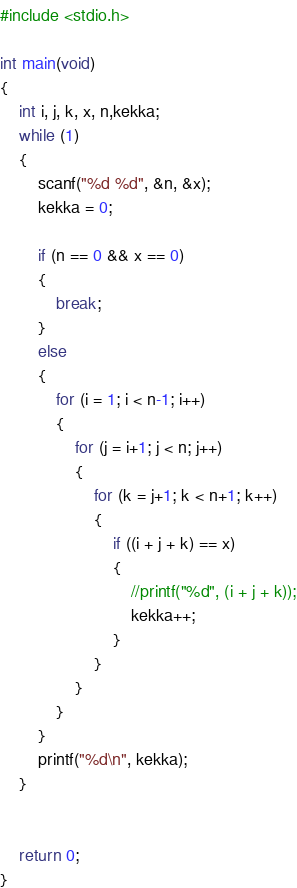Convert code to text. <code><loc_0><loc_0><loc_500><loc_500><_C_>#include <stdio.h>

int main(void)
{
	int i, j, k, x, n,kekka;
	while (1)
	{
		scanf("%d %d", &n, &x);
		kekka = 0;

		if (n == 0 && x == 0)
		{
			break;
		}
		else
		{
			for (i = 1; i < n-1; i++)
			{
				for (j = i+1; j < n; j++)
				{
					for (k = j+1; k < n+1; k++)
					{
						if ((i + j + k) == x)
						{
							//printf("%d", (i + j + k));
							kekka++;
						}
					}
				}
			}
		}
		printf("%d\n", kekka);
	}

	
	return 0;
}
</code> 